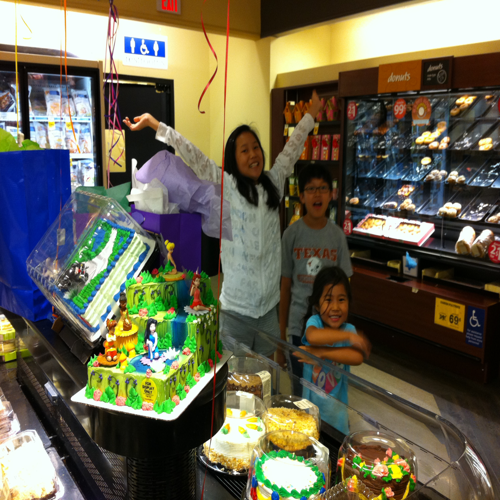Are there any interesting design elements on the cake? The cake is elaborately decorated with vibrant colors and multiple tiers. It features edible figurines that might represent characters or themes from a story or a popular franchise. There are also intricate icing patterns and decorative bordering which make it visually compelling. 